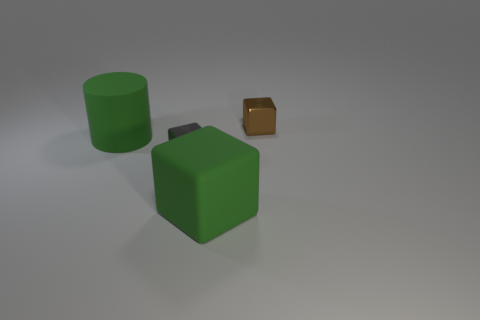Is the color of the large matte cube the same as the large cylinder?
Your response must be concise. Yes. What is the cylinder made of?
Keep it short and to the point. Rubber. There is a object that is made of the same material as the large green cube; what color is it?
Your response must be concise. Green. There is a small cube in front of the big green matte cylinder; is there a large green matte cylinder that is right of it?
Keep it short and to the point. No. What number of other objects are the same shape as the small brown shiny thing?
Provide a short and direct response. 2. Does the large object that is behind the gray metal object have the same shape as the shiny thing on the left side of the large matte block?
Keep it short and to the point. No. How many tiny brown shiny cubes are behind the large thing that is in front of the small metallic object in front of the brown thing?
Your response must be concise. 1. What color is the rubber cylinder?
Offer a very short reply. Green. How many other things are the same size as the rubber cylinder?
Keep it short and to the point. 1. What material is the other big object that is the same shape as the brown object?
Keep it short and to the point. Rubber. 